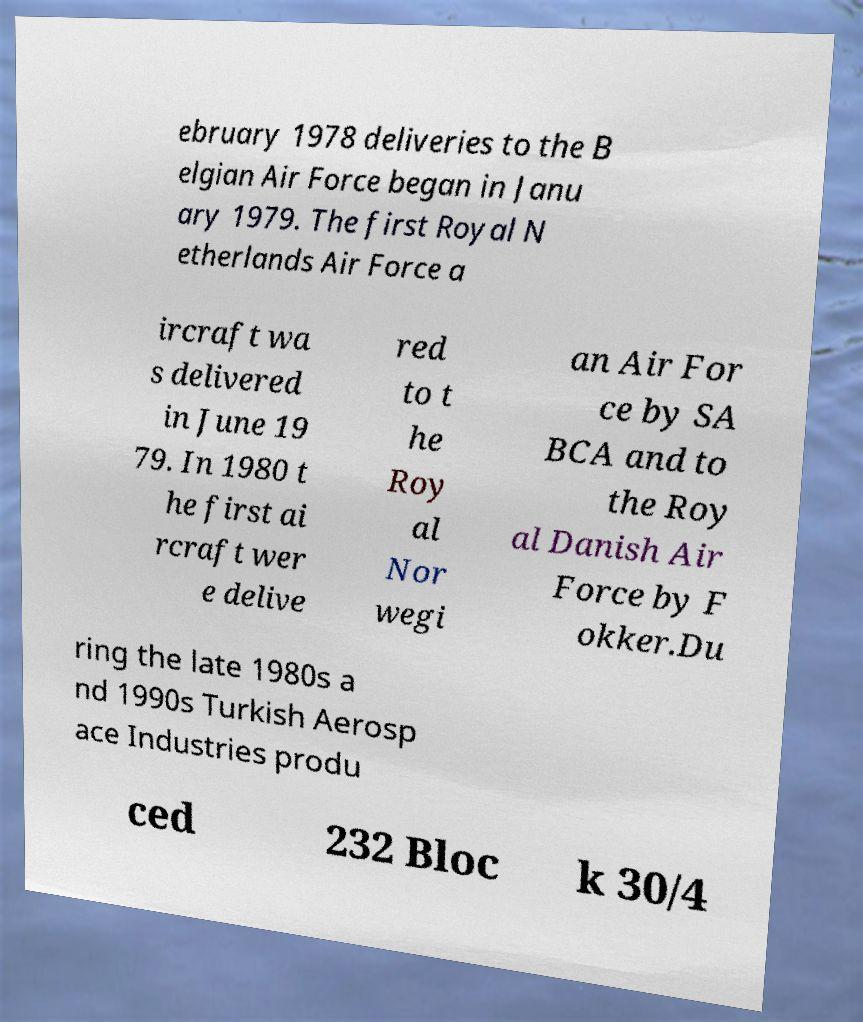Could you extract and type out the text from this image? ebruary 1978 deliveries to the B elgian Air Force began in Janu ary 1979. The first Royal N etherlands Air Force a ircraft wa s delivered in June 19 79. In 1980 t he first ai rcraft wer e delive red to t he Roy al Nor wegi an Air For ce by SA BCA and to the Roy al Danish Air Force by F okker.Du ring the late 1980s a nd 1990s Turkish Aerosp ace Industries produ ced 232 Bloc k 30/4 